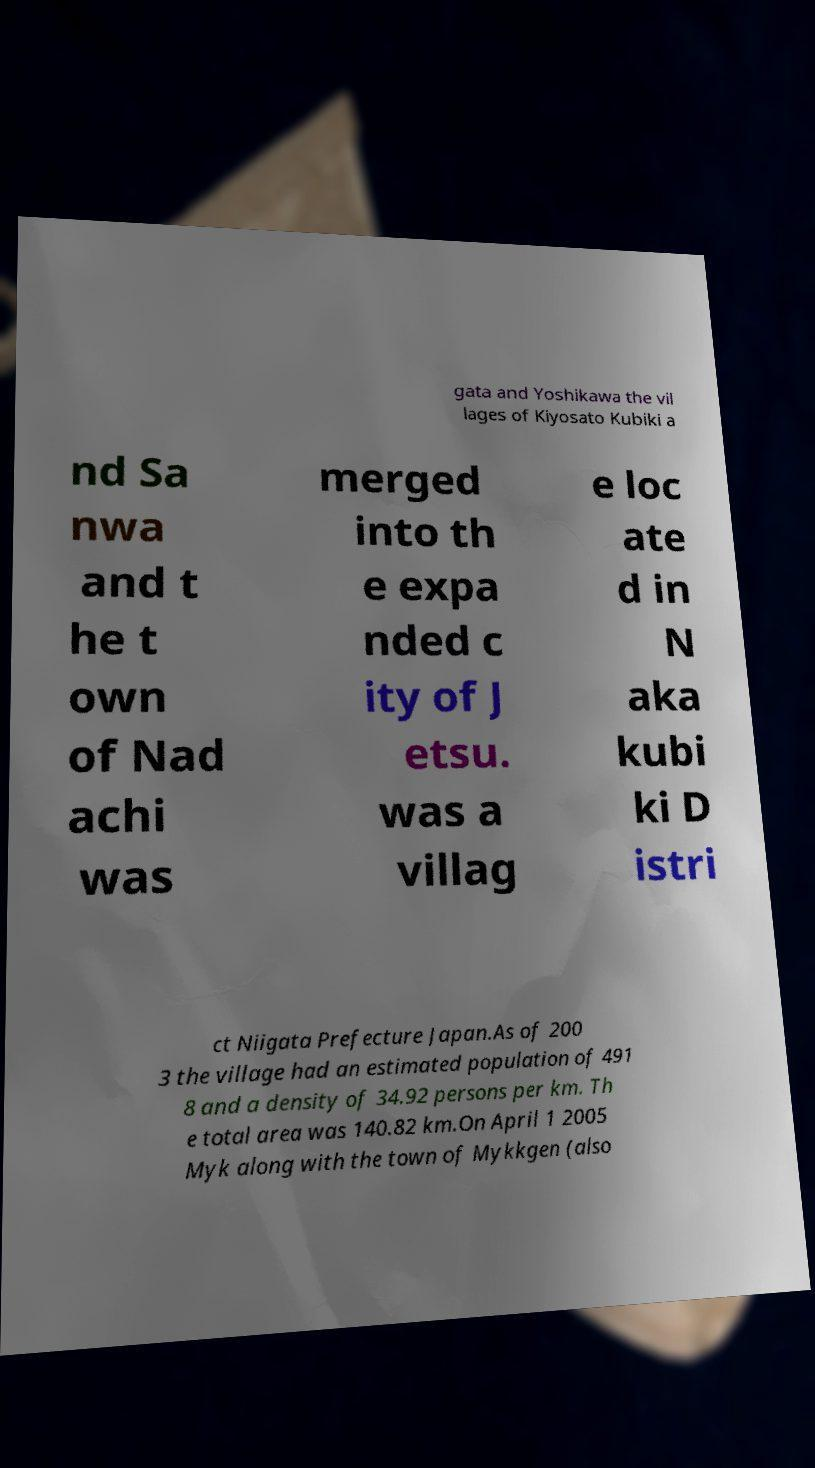Can you read and provide the text displayed in the image?This photo seems to have some interesting text. Can you extract and type it out for me? gata and Yoshikawa the vil lages of Kiyosato Kubiki a nd Sa nwa and t he t own of Nad achi was merged into th e expa nded c ity of J etsu. was a villag e loc ate d in N aka kubi ki D istri ct Niigata Prefecture Japan.As of 200 3 the village had an estimated population of 491 8 and a density of 34.92 persons per km. Th e total area was 140.82 km.On April 1 2005 Myk along with the town of Mykkgen (also 